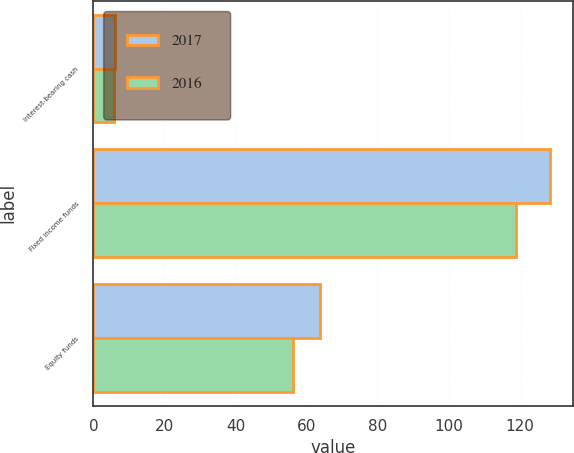Convert chart to OTSL. <chart><loc_0><loc_0><loc_500><loc_500><stacked_bar_chart><ecel><fcel>Interest-bearing cash<fcel>Fixed income funds<fcel>Equity funds<nl><fcel>2017<fcel>6.2<fcel>128.7<fcel>63.9<nl><fcel>2016<fcel>5.7<fcel>119<fcel>56.3<nl></chart> 